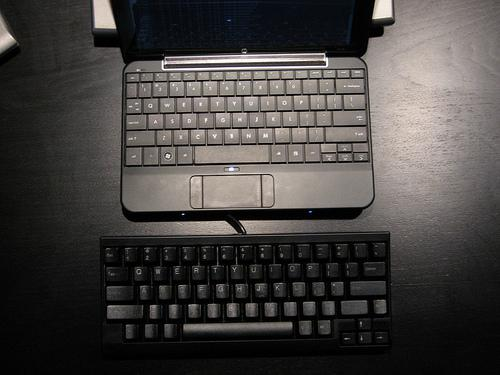Question: where is the external keyboard?
Choices:
A. Below the laptop.
B. In the box.
C. To the right of the laptop.
D. To the left of the laptop.
Answer with the letter. Answer: A Question: what color are the lights on front of the laptop?
Choices:
A. Red.
B. Blue.
C. Yellow.
D. Green.
Answer with the letter. Answer: B Question: what color is the background of the image?
Choices:
A. Black.
B. Grey.
C. Brown.
D. Pink.
Answer with the letter. Answer: A Question: where is the trackpad?
Choices:
A. On the laptop.
B. In the box.
C. On the brochure.
D. There is no trackpad.
Answer with the letter. Answer: A 